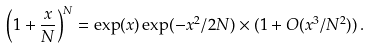<formula> <loc_0><loc_0><loc_500><loc_500>\left ( 1 + \frac { x } { N } \right ) ^ { N } = \exp ( x ) \exp ( - x ^ { 2 } / 2 N ) \times ( 1 + O ( x ^ { 3 } / N ^ { 2 } ) ) \, .</formula> 